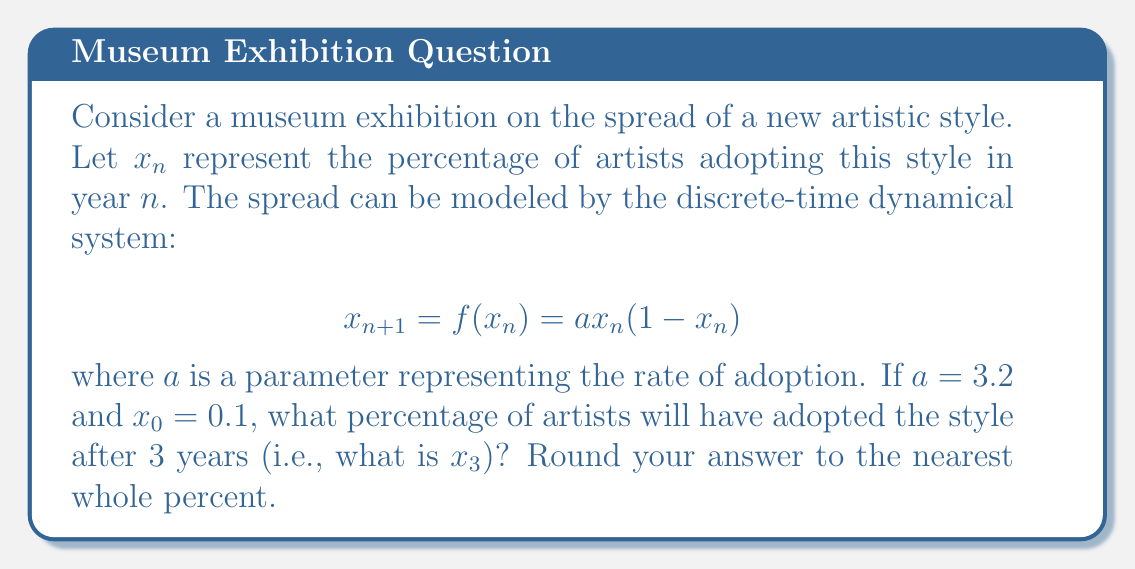Show me your answer to this math problem. To solve this problem, we need to iterate the given function three times, starting with $x_0 = 0.1$. Let's go through this step-by-step:

1) First, let's calculate $x_1$:
   $$x_1 = f(x_0) = 3.2 \cdot 0.1 \cdot (1-0.1) = 3.2 \cdot 0.1 \cdot 0.9 = 0.288$$

2) Now, let's calculate $x_2$:
   $$x_2 = f(x_1) = 3.2 \cdot 0.288 \cdot (1-0.288) = 3.2 \cdot 0.288 \cdot 0.712 = 0.656$$

3) Finally, let's calculate $x_3$:
   $$x_3 = f(x_2) = 3.2 \cdot 0.656 \cdot (1-0.656) = 3.2 \cdot 0.656 \cdot 0.344 = 0.722$$

4) Converting to a percentage and rounding to the nearest whole number:
   $0.722 \cdot 100\% \approx 72\%$

Therefore, after 3 years, approximately 72% of artists will have adopted the new style.
Answer: 72% 